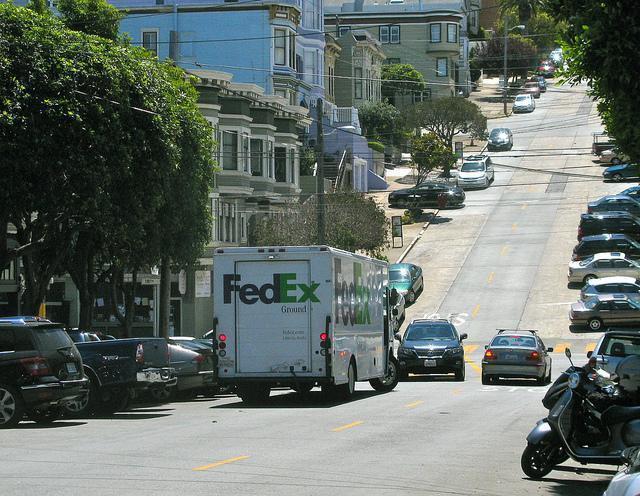Which car is in greatest danger if the FedEx car rushed forward?
Answer the question by selecting the correct answer among the 4 following choices and explain your choice with a short sentence. The answer should be formatted with the following format: `Answer: choice
Rationale: rationale.`
Options: Blue suv, silver sedan, motorcycle, black truck. Answer: blue suv.
Rationale: The blue suv is right in front of the fedex truck. 